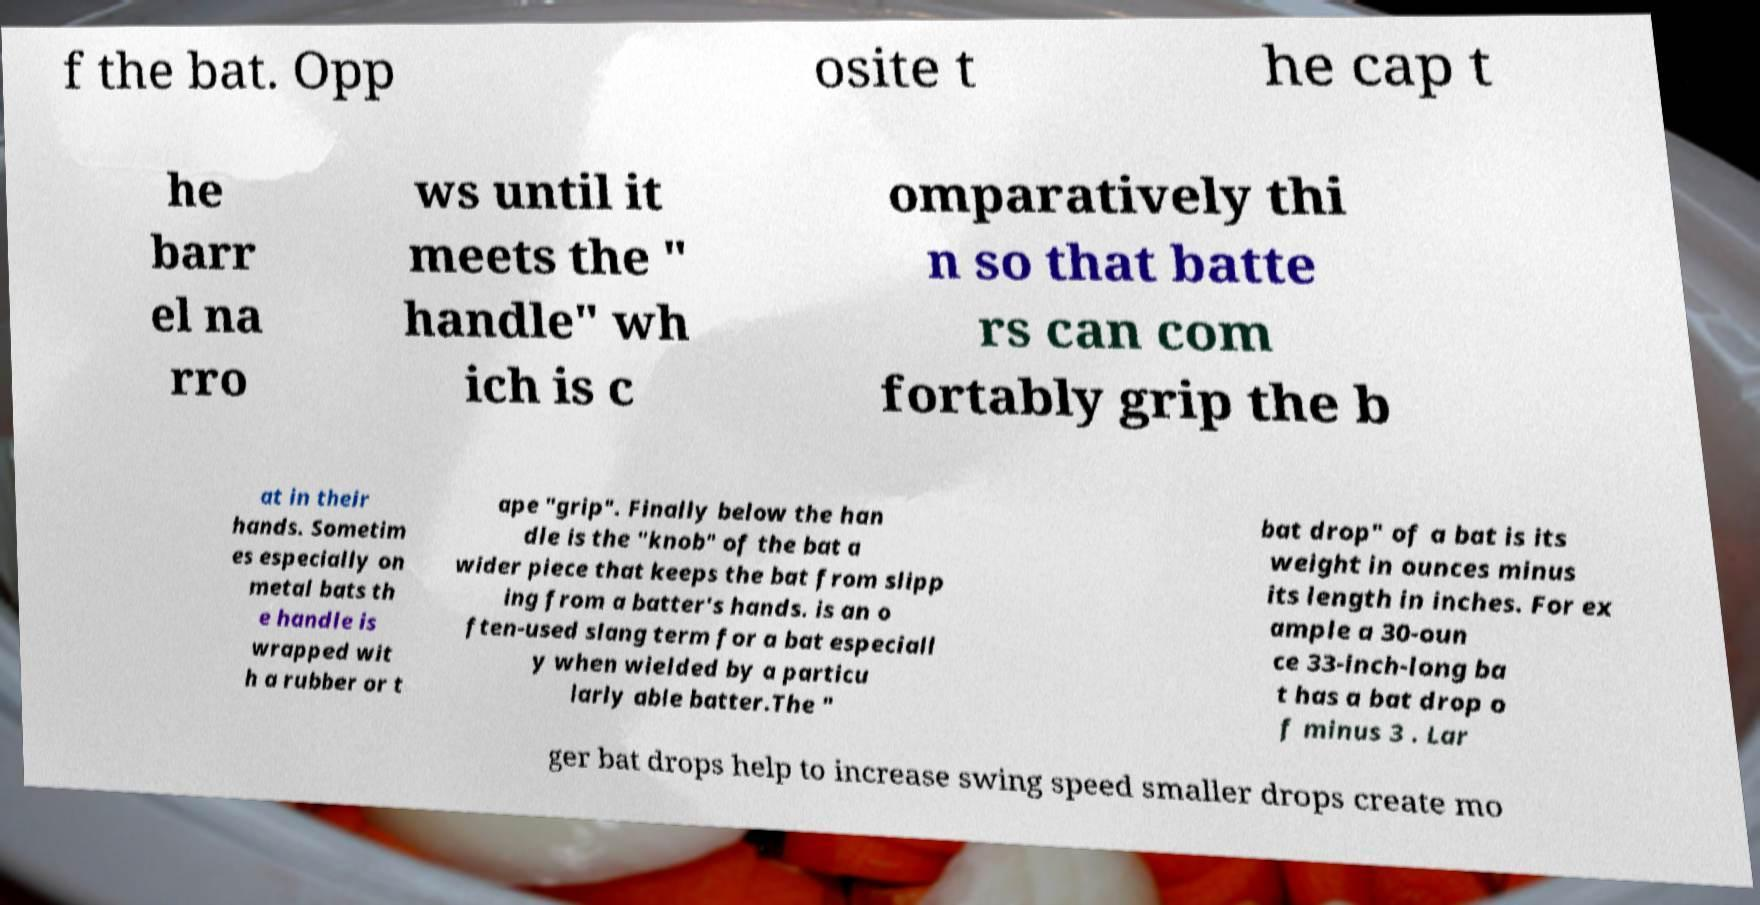I need the written content from this picture converted into text. Can you do that? f the bat. Opp osite t he cap t he barr el na rro ws until it meets the " handle" wh ich is c omparatively thi n so that batte rs can com fortably grip the b at in their hands. Sometim es especially on metal bats th e handle is wrapped wit h a rubber or t ape "grip". Finally below the han dle is the "knob" of the bat a wider piece that keeps the bat from slipp ing from a batter's hands. is an o ften-used slang term for a bat especiall y when wielded by a particu larly able batter.The " bat drop" of a bat is its weight in ounces minus its length in inches. For ex ample a 30-oun ce 33-inch-long ba t has a bat drop o f minus 3 . Lar ger bat drops help to increase swing speed smaller drops create mo 